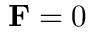<formula> <loc_0><loc_0><loc_500><loc_500>F = 0</formula> 